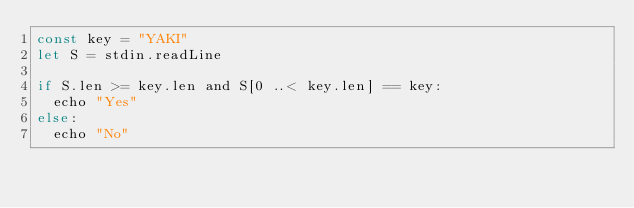<code> <loc_0><loc_0><loc_500><loc_500><_Nim_>const key = "YAKI"
let S = stdin.readLine

if S.len >= key.len and S[0 ..< key.len] == key:
  echo "Yes"
else:
  echo "No"
</code> 